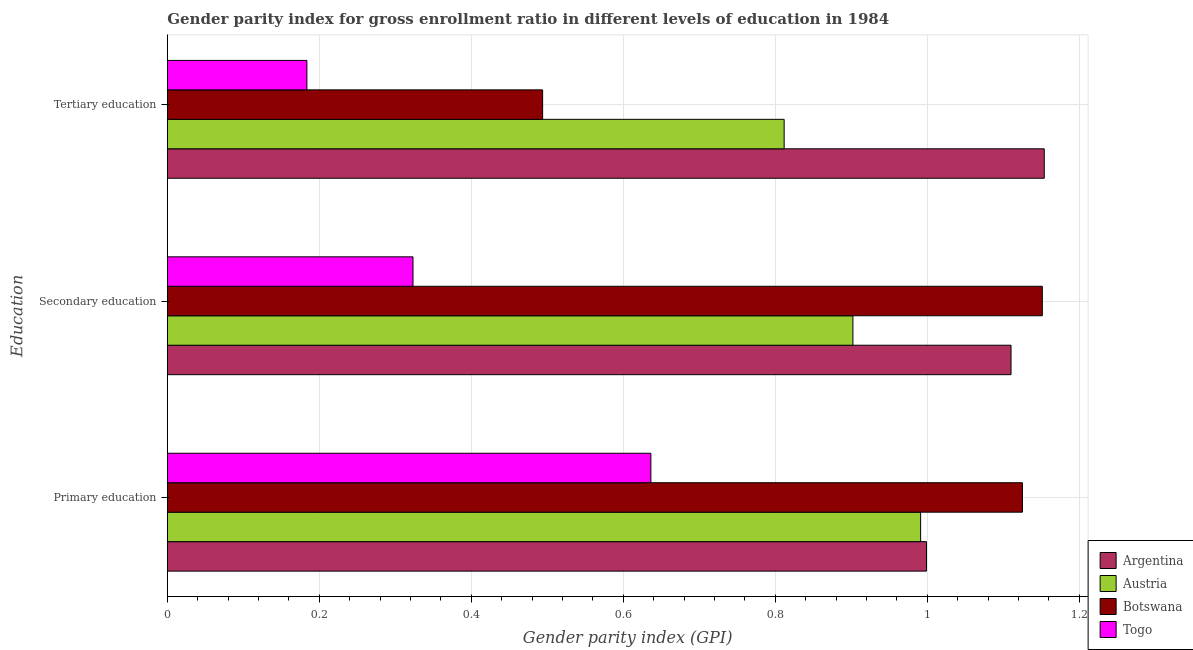How many groups of bars are there?
Your answer should be very brief. 3. Are the number of bars per tick equal to the number of legend labels?
Provide a succinct answer. Yes. Are the number of bars on each tick of the Y-axis equal?
Your answer should be compact. Yes. How many bars are there on the 3rd tick from the bottom?
Provide a short and direct response. 4. What is the label of the 3rd group of bars from the top?
Your answer should be very brief. Primary education. What is the gender parity index in primary education in Argentina?
Make the answer very short. 1. Across all countries, what is the maximum gender parity index in primary education?
Keep it short and to the point. 1.13. Across all countries, what is the minimum gender parity index in secondary education?
Offer a terse response. 0.32. In which country was the gender parity index in tertiary education minimum?
Provide a succinct answer. Togo. What is the total gender parity index in tertiary education in the graph?
Provide a succinct answer. 2.64. What is the difference between the gender parity index in secondary education in Botswana and that in Austria?
Ensure brevity in your answer.  0.25. What is the difference between the gender parity index in tertiary education in Argentina and the gender parity index in secondary education in Togo?
Keep it short and to the point. 0.83. What is the average gender parity index in secondary education per country?
Your answer should be compact. 0.87. What is the difference between the gender parity index in primary education and gender parity index in secondary education in Argentina?
Your response must be concise. -0.11. What is the ratio of the gender parity index in secondary education in Togo to that in Austria?
Give a very brief answer. 0.36. Is the gender parity index in secondary education in Botswana less than that in Austria?
Provide a succinct answer. No. What is the difference between the highest and the second highest gender parity index in secondary education?
Provide a succinct answer. 0.04. What is the difference between the highest and the lowest gender parity index in secondary education?
Make the answer very short. 0.83. In how many countries, is the gender parity index in tertiary education greater than the average gender parity index in tertiary education taken over all countries?
Give a very brief answer. 2. What does the 3rd bar from the bottom in Secondary education represents?
Offer a very short reply. Botswana. How many countries are there in the graph?
Give a very brief answer. 4. What is the difference between two consecutive major ticks on the X-axis?
Provide a succinct answer. 0.2. Where does the legend appear in the graph?
Your answer should be very brief. Bottom right. How many legend labels are there?
Offer a very short reply. 4. How are the legend labels stacked?
Provide a short and direct response. Vertical. What is the title of the graph?
Keep it short and to the point. Gender parity index for gross enrollment ratio in different levels of education in 1984. What is the label or title of the X-axis?
Give a very brief answer. Gender parity index (GPI). What is the label or title of the Y-axis?
Provide a short and direct response. Education. What is the Gender parity index (GPI) of Argentina in Primary education?
Give a very brief answer. 1. What is the Gender parity index (GPI) of Austria in Primary education?
Offer a terse response. 0.99. What is the Gender parity index (GPI) of Botswana in Primary education?
Keep it short and to the point. 1.13. What is the Gender parity index (GPI) of Togo in Primary education?
Offer a terse response. 0.64. What is the Gender parity index (GPI) of Argentina in Secondary education?
Your answer should be compact. 1.11. What is the Gender parity index (GPI) in Austria in Secondary education?
Your response must be concise. 0.9. What is the Gender parity index (GPI) in Botswana in Secondary education?
Make the answer very short. 1.15. What is the Gender parity index (GPI) in Togo in Secondary education?
Provide a succinct answer. 0.32. What is the Gender parity index (GPI) of Argentina in Tertiary education?
Give a very brief answer. 1.15. What is the Gender parity index (GPI) in Austria in Tertiary education?
Offer a terse response. 0.81. What is the Gender parity index (GPI) in Botswana in Tertiary education?
Make the answer very short. 0.49. What is the Gender parity index (GPI) in Togo in Tertiary education?
Offer a very short reply. 0.18. Across all Education, what is the maximum Gender parity index (GPI) in Argentina?
Provide a short and direct response. 1.15. Across all Education, what is the maximum Gender parity index (GPI) in Austria?
Offer a very short reply. 0.99. Across all Education, what is the maximum Gender parity index (GPI) in Botswana?
Your answer should be very brief. 1.15. Across all Education, what is the maximum Gender parity index (GPI) in Togo?
Provide a succinct answer. 0.64. Across all Education, what is the minimum Gender parity index (GPI) of Argentina?
Keep it short and to the point. 1. Across all Education, what is the minimum Gender parity index (GPI) in Austria?
Make the answer very short. 0.81. Across all Education, what is the minimum Gender parity index (GPI) of Botswana?
Your answer should be compact. 0.49. Across all Education, what is the minimum Gender parity index (GPI) in Togo?
Make the answer very short. 0.18. What is the total Gender parity index (GPI) of Argentina in the graph?
Provide a short and direct response. 3.26. What is the total Gender parity index (GPI) of Austria in the graph?
Offer a very short reply. 2.7. What is the total Gender parity index (GPI) of Botswana in the graph?
Offer a very short reply. 2.77. What is the difference between the Gender parity index (GPI) of Argentina in Primary education and that in Secondary education?
Your answer should be compact. -0.11. What is the difference between the Gender parity index (GPI) in Austria in Primary education and that in Secondary education?
Your answer should be very brief. 0.09. What is the difference between the Gender parity index (GPI) of Botswana in Primary education and that in Secondary education?
Make the answer very short. -0.03. What is the difference between the Gender parity index (GPI) of Togo in Primary education and that in Secondary education?
Make the answer very short. 0.31. What is the difference between the Gender parity index (GPI) of Argentina in Primary education and that in Tertiary education?
Offer a terse response. -0.15. What is the difference between the Gender parity index (GPI) of Austria in Primary education and that in Tertiary education?
Provide a succinct answer. 0.18. What is the difference between the Gender parity index (GPI) of Botswana in Primary education and that in Tertiary education?
Make the answer very short. 0.63. What is the difference between the Gender parity index (GPI) in Togo in Primary education and that in Tertiary education?
Provide a short and direct response. 0.45. What is the difference between the Gender parity index (GPI) in Argentina in Secondary education and that in Tertiary education?
Provide a succinct answer. -0.04. What is the difference between the Gender parity index (GPI) of Austria in Secondary education and that in Tertiary education?
Your answer should be compact. 0.09. What is the difference between the Gender parity index (GPI) in Botswana in Secondary education and that in Tertiary education?
Make the answer very short. 0.66. What is the difference between the Gender parity index (GPI) in Togo in Secondary education and that in Tertiary education?
Give a very brief answer. 0.14. What is the difference between the Gender parity index (GPI) in Argentina in Primary education and the Gender parity index (GPI) in Austria in Secondary education?
Offer a terse response. 0.1. What is the difference between the Gender parity index (GPI) in Argentina in Primary education and the Gender parity index (GPI) in Botswana in Secondary education?
Make the answer very short. -0.15. What is the difference between the Gender parity index (GPI) of Argentina in Primary education and the Gender parity index (GPI) of Togo in Secondary education?
Offer a terse response. 0.68. What is the difference between the Gender parity index (GPI) of Austria in Primary education and the Gender parity index (GPI) of Botswana in Secondary education?
Your answer should be very brief. -0.16. What is the difference between the Gender parity index (GPI) of Austria in Primary education and the Gender parity index (GPI) of Togo in Secondary education?
Ensure brevity in your answer.  0.67. What is the difference between the Gender parity index (GPI) in Botswana in Primary education and the Gender parity index (GPI) in Togo in Secondary education?
Give a very brief answer. 0.8. What is the difference between the Gender parity index (GPI) of Argentina in Primary education and the Gender parity index (GPI) of Austria in Tertiary education?
Ensure brevity in your answer.  0.19. What is the difference between the Gender parity index (GPI) of Argentina in Primary education and the Gender parity index (GPI) of Botswana in Tertiary education?
Give a very brief answer. 0.51. What is the difference between the Gender parity index (GPI) in Argentina in Primary education and the Gender parity index (GPI) in Togo in Tertiary education?
Make the answer very short. 0.82. What is the difference between the Gender parity index (GPI) of Austria in Primary education and the Gender parity index (GPI) of Botswana in Tertiary education?
Your response must be concise. 0.5. What is the difference between the Gender parity index (GPI) in Austria in Primary education and the Gender parity index (GPI) in Togo in Tertiary education?
Your response must be concise. 0.81. What is the difference between the Gender parity index (GPI) of Botswana in Primary education and the Gender parity index (GPI) of Togo in Tertiary education?
Make the answer very short. 0.94. What is the difference between the Gender parity index (GPI) of Argentina in Secondary education and the Gender parity index (GPI) of Austria in Tertiary education?
Keep it short and to the point. 0.3. What is the difference between the Gender parity index (GPI) of Argentina in Secondary education and the Gender parity index (GPI) of Botswana in Tertiary education?
Make the answer very short. 0.62. What is the difference between the Gender parity index (GPI) in Argentina in Secondary education and the Gender parity index (GPI) in Togo in Tertiary education?
Your answer should be compact. 0.93. What is the difference between the Gender parity index (GPI) of Austria in Secondary education and the Gender parity index (GPI) of Botswana in Tertiary education?
Your answer should be very brief. 0.41. What is the difference between the Gender parity index (GPI) of Austria in Secondary education and the Gender parity index (GPI) of Togo in Tertiary education?
Your answer should be very brief. 0.72. What is the average Gender parity index (GPI) in Argentina per Education?
Make the answer very short. 1.09. What is the average Gender parity index (GPI) in Austria per Education?
Your answer should be very brief. 0.9. What is the average Gender parity index (GPI) of Botswana per Education?
Your answer should be compact. 0.92. What is the average Gender parity index (GPI) of Togo per Education?
Ensure brevity in your answer.  0.38. What is the difference between the Gender parity index (GPI) in Argentina and Gender parity index (GPI) in Austria in Primary education?
Make the answer very short. 0.01. What is the difference between the Gender parity index (GPI) in Argentina and Gender parity index (GPI) in Botswana in Primary education?
Your answer should be very brief. -0.13. What is the difference between the Gender parity index (GPI) of Argentina and Gender parity index (GPI) of Togo in Primary education?
Give a very brief answer. 0.36. What is the difference between the Gender parity index (GPI) in Austria and Gender parity index (GPI) in Botswana in Primary education?
Provide a succinct answer. -0.13. What is the difference between the Gender parity index (GPI) of Austria and Gender parity index (GPI) of Togo in Primary education?
Provide a succinct answer. 0.35. What is the difference between the Gender parity index (GPI) of Botswana and Gender parity index (GPI) of Togo in Primary education?
Your answer should be compact. 0.49. What is the difference between the Gender parity index (GPI) of Argentina and Gender parity index (GPI) of Austria in Secondary education?
Ensure brevity in your answer.  0.21. What is the difference between the Gender parity index (GPI) in Argentina and Gender parity index (GPI) in Botswana in Secondary education?
Your response must be concise. -0.04. What is the difference between the Gender parity index (GPI) of Argentina and Gender parity index (GPI) of Togo in Secondary education?
Offer a very short reply. 0.79. What is the difference between the Gender parity index (GPI) in Austria and Gender parity index (GPI) in Botswana in Secondary education?
Provide a short and direct response. -0.25. What is the difference between the Gender parity index (GPI) in Austria and Gender parity index (GPI) in Togo in Secondary education?
Provide a short and direct response. 0.58. What is the difference between the Gender parity index (GPI) of Botswana and Gender parity index (GPI) of Togo in Secondary education?
Ensure brevity in your answer.  0.83. What is the difference between the Gender parity index (GPI) in Argentina and Gender parity index (GPI) in Austria in Tertiary education?
Your response must be concise. 0.34. What is the difference between the Gender parity index (GPI) of Argentina and Gender parity index (GPI) of Botswana in Tertiary education?
Your answer should be very brief. 0.66. What is the difference between the Gender parity index (GPI) in Argentina and Gender parity index (GPI) in Togo in Tertiary education?
Give a very brief answer. 0.97. What is the difference between the Gender parity index (GPI) of Austria and Gender parity index (GPI) of Botswana in Tertiary education?
Keep it short and to the point. 0.32. What is the difference between the Gender parity index (GPI) in Austria and Gender parity index (GPI) in Togo in Tertiary education?
Make the answer very short. 0.63. What is the difference between the Gender parity index (GPI) in Botswana and Gender parity index (GPI) in Togo in Tertiary education?
Offer a very short reply. 0.31. What is the ratio of the Gender parity index (GPI) in Argentina in Primary education to that in Secondary education?
Your answer should be compact. 0.9. What is the ratio of the Gender parity index (GPI) of Austria in Primary education to that in Secondary education?
Your answer should be very brief. 1.1. What is the ratio of the Gender parity index (GPI) in Botswana in Primary education to that in Secondary education?
Offer a terse response. 0.98. What is the ratio of the Gender parity index (GPI) of Togo in Primary education to that in Secondary education?
Your answer should be compact. 1.97. What is the ratio of the Gender parity index (GPI) of Argentina in Primary education to that in Tertiary education?
Keep it short and to the point. 0.87. What is the ratio of the Gender parity index (GPI) of Austria in Primary education to that in Tertiary education?
Your answer should be very brief. 1.22. What is the ratio of the Gender parity index (GPI) of Botswana in Primary education to that in Tertiary education?
Offer a terse response. 2.28. What is the ratio of the Gender parity index (GPI) in Togo in Primary education to that in Tertiary education?
Your answer should be very brief. 3.47. What is the ratio of the Gender parity index (GPI) of Argentina in Secondary education to that in Tertiary education?
Offer a very short reply. 0.96. What is the ratio of the Gender parity index (GPI) of Austria in Secondary education to that in Tertiary education?
Your response must be concise. 1.11. What is the ratio of the Gender parity index (GPI) in Botswana in Secondary education to that in Tertiary education?
Offer a terse response. 2.33. What is the ratio of the Gender parity index (GPI) in Togo in Secondary education to that in Tertiary education?
Offer a very short reply. 1.76. What is the difference between the highest and the second highest Gender parity index (GPI) of Argentina?
Your response must be concise. 0.04. What is the difference between the highest and the second highest Gender parity index (GPI) of Austria?
Your answer should be very brief. 0.09. What is the difference between the highest and the second highest Gender parity index (GPI) of Botswana?
Your answer should be very brief. 0.03. What is the difference between the highest and the second highest Gender parity index (GPI) in Togo?
Your response must be concise. 0.31. What is the difference between the highest and the lowest Gender parity index (GPI) of Argentina?
Keep it short and to the point. 0.15. What is the difference between the highest and the lowest Gender parity index (GPI) in Austria?
Give a very brief answer. 0.18. What is the difference between the highest and the lowest Gender parity index (GPI) of Botswana?
Keep it short and to the point. 0.66. What is the difference between the highest and the lowest Gender parity index (GPI) in Togo?
Make the answer very short. 0.45. 